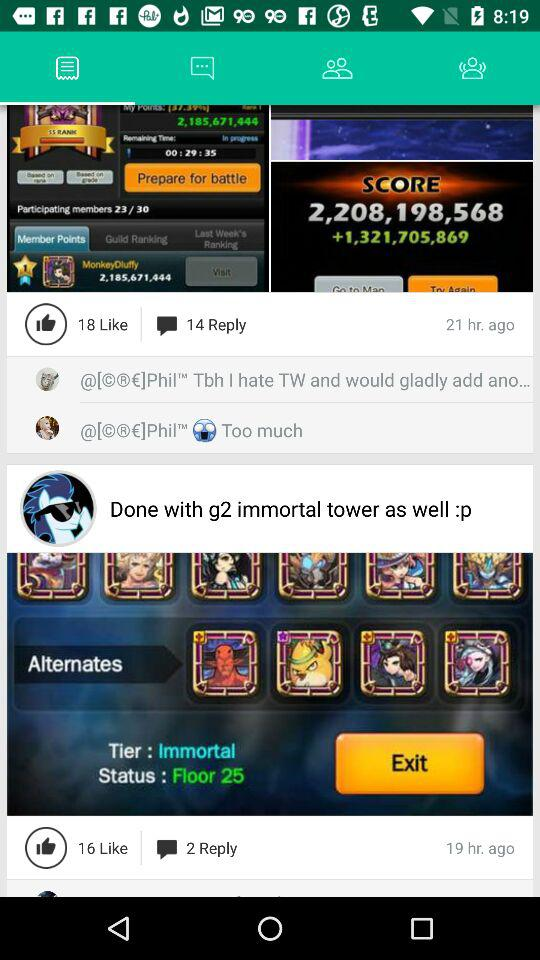What is the number of minimum like?
When the provided information is insufficient, respond with <no answer>. <no answer> 